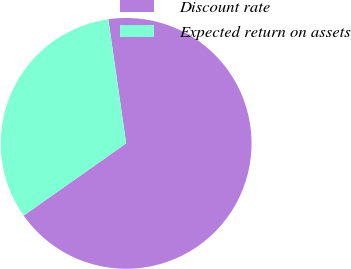<chart> <loc_0><loc_0><loc_500><loc_500><pie_chart><fcel>Discount rate<fcel>Expected return on assets<nl><fcel>67.5%<fcel>32.5%<nl></chart> 